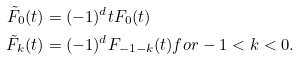Convert formula to latex. <formula><loc_0><loc_0><loc_500><loc_500>\tilde { F } _ { 0 } ( t ) & = ( - 1 ) ^ { d } t F _ { 0 } ( t ) \\ \tilde { F } _ { k } ( t ) & = ( - 1 ) ^ { d } F _ { - 1 - k } ( t ) f o r - 1 < k < 0 .</formula> 